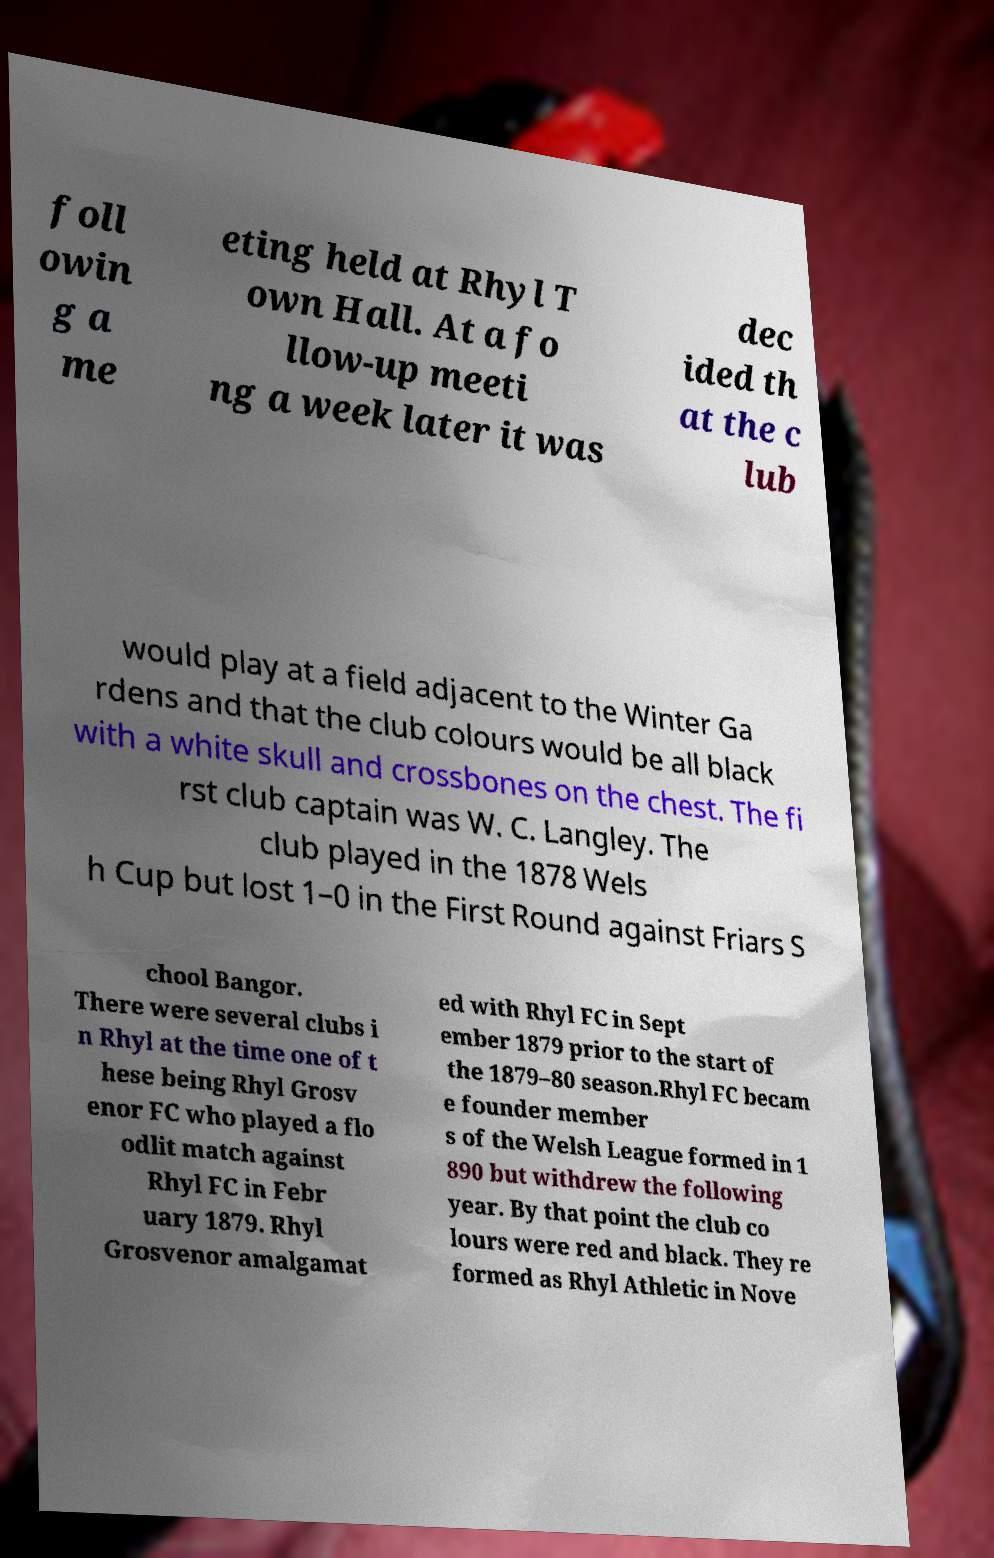Can you accurately transcribe the text from the provided image for me? foll owin g a me eting held at Rhyl T own Hall. At a fo llow-up meeti ng a week later it was dec ided th at the c lub would play at a field adjacent to the Winter Ga rdens and that the club colours would be all black with a white skull and crossbones on the chest. The fi rst club captain was W. C. Langley. The club played in the 1878 Wels h Cup but lost 1–0 in the First Round against Friars S chool Bangor. There were several clubs i n Rhyl at the time one of t hese being Rhyl Grosv enor FC who played a flo odlit match against Rhyl FC in Febr uary 1879. Rhyl Grosvenor amalgamat ed with Rhyl FC in Sept ember 1879 prior to the start of the 1879–80 season.Rhyl FC becam e founder member s of the Welsh League formed in 1 890 but withdrew the following year. By that point the club co lours were red and black. They re formed as Rhyl Athletic in Nove 